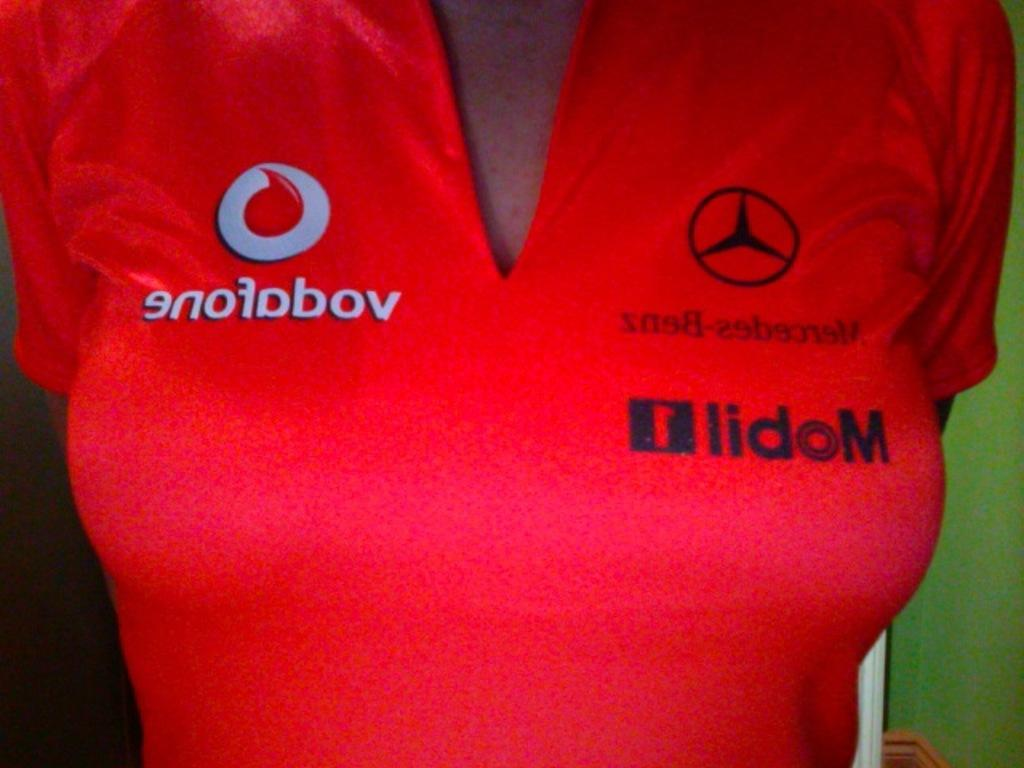<image>
Give a short and clear explanation of the subsequent image. The word vodafone and Mercedes Benz is reversed on this red top. 